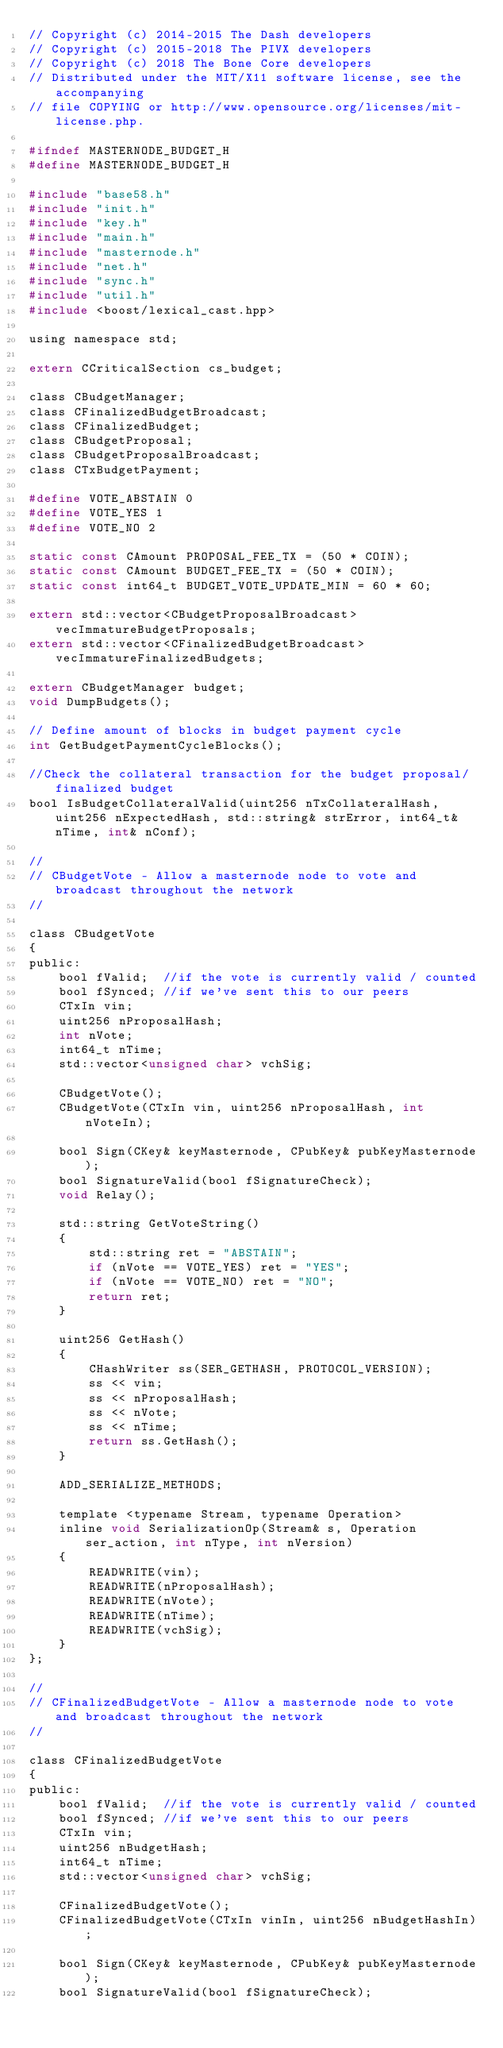Convert code to text. <code><loc_0><loc_0><loc_500><loc_500><_C_>// Copyright (c) 2014-2015 The Dash developers
// Copyright (c) 2015-2018 The PIVX developers
// Copyright (c) 2018 The Bone Core developers
// Distributed under the MIT/X11 software license, see the accompanying
// file COPYING or http://www.opensource.org/licenses/mit-license.php.

#ifndef MASTERNODE_BUDGET_H
#define MASTERNODE_BUDGET_H

#include "base58.h"
#include "init.h"
#include "key.h"
#include "main.h"
#include "masternode.h"
#include "net.h"
#include "sync.h"
#include "util.h"
#include <boost/lexical_cast.hpp>

using namespace std;

extern CCriticalSection cs_budget;

class CBudgetManager;
class CFinalizedBudgetBroadcast;
class CFinalizedBudget;
class CBudgetProposal;
class CBudgetProposalBroadcast;
class CTxBudgetPayment;

#define VOTE_ABSTAIN 0
#define VOTE_YES 1
#define VOTE_NO 2

static const CAmount PROPOSAL_FEE_TX = (50 * COIN);
static const CAmount BUDGET_FEE_TX = (50 * COIN);
static const int64_t BUDGET_VOTE_UPDATE_MIN = 60 * 60;

extern std::vector<CBudgetProposalBroadcast> vecImmatureBudgetProposals;
extern std::vector<CFinalizedBudgetBroadcast> vecImmatureFinalizedBudgets;

extern CBudgetManager budget;
void DumpBudgets();

// Define amount of blocks in budget payment cycle
int GetBudgetPaymentCycleBlocks();

//Check the collateral transaction for the budget proposal/finalized budget
bool IsBudgetCollateralValid(uint256 nTxCollateralHash, uint256 nExpectedHash, std::string& strError, int64_t& nTime, int& nConf);

//
// CBudgetVote - Allow a masternode node to vote and broadcast throughout the network
//

class CBudgetVote
{
public:
    bool fValid;  //if the vote is currently valid / counted
    bool fSynced; //if we've sent this to our peers
    CTxIn vin;
    uint256 nProposalHash;
    int nVote;
    int64_t nTime;
    std::vector<unsigned char> vchSig;

    CBudgetVote();
    CBudgetVote(CTxIn vin, uint256 nProposalHash, int nVoteIn);

    bool Sign(CKey& keyMasternode, CPubKey& pubKeyMasternode);
    bool SignatureValid(bool fSignatureCheck);
    void Relay();

    std::string GetVoteString()
    {
        std::string ret = "ABSTAIN";
        if (nVote == VOTE_YES) ret = "YES";
        if (nVote == VOTE_NO) ret = "NO";
        return ret;
    }

    uint256 GetHash()
    {
        CHashWriter ss(SER_GETHASH, PROTOCOL_VERSION);
        ss << vin;
        ss << nProposalHash;
        ss << nVote;
        ss << nTime;
        return ss.GetHash();
    }

    ADD_SERIALIZE_METHODS;

    template <typename Stream, typename Operation>
    inline void SerializationOp(Stream& s, Operation ser_action, int nType, int nVersion)
    {
        READWRITE(vin);
        READWRITE(nProposalHash);
        READWRITE(nVote);
        READWRITE(nTime);
        READWRITE(vchSig);
    }
};

//
// CFinalizedBudgetVote - Allow a masternode node to vote and broadcast throughout the network
//

class CFinalizedBudgetVote
{
public:
    bool fValid;  //if the vote is currently valid / counted
    bool fSynced; //if we've sent this to our peers
    CTxIn vin;
    uint256 nBudgetHash;
    int64_t nTime;
    std::vector<unsigned char> vchSig;

    CFinalizedBudgetVote();
    CFinalizedBudgetVote(CTxIn vinIn, uint256 nBudgetHashIn);

    bool Sign(CKey& keyMasternode, CPubKey& pubKeyMasternode);
    bool SignatureValid(bool fSignatureCheck);</code> 